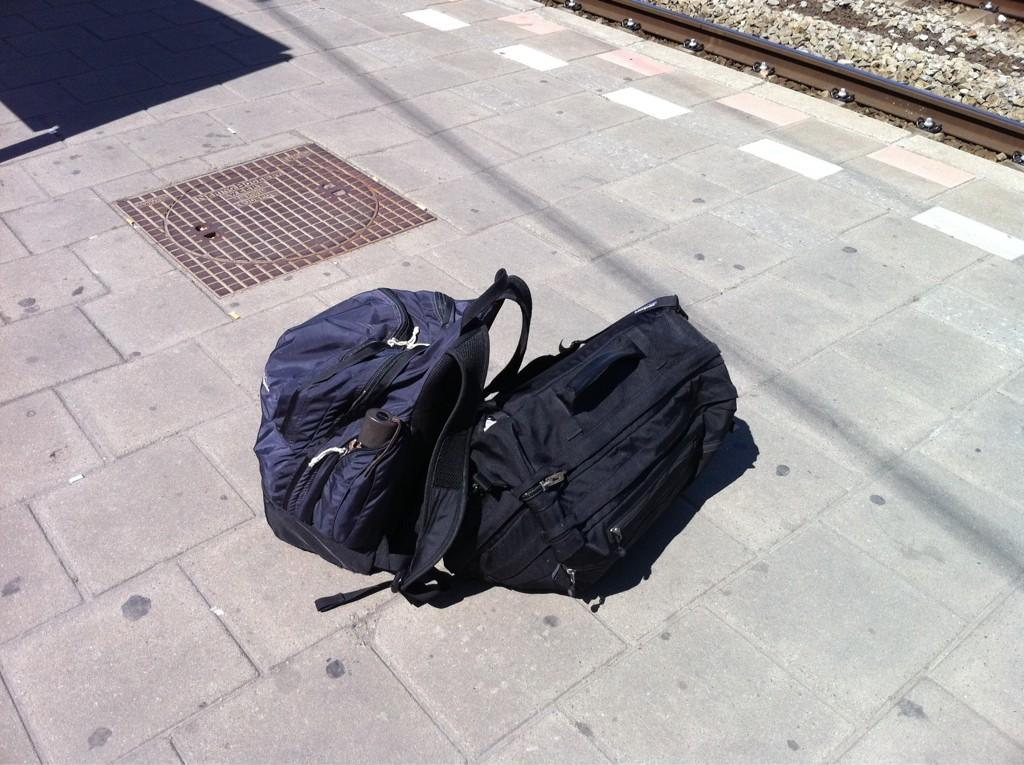What objects are on the platform in the image? There are two blue bags on a platform in the image. What other features can be seen in the image? There is a manhole lid, a shadow casting of a sign board, and a rail of a railway track in the image. What type of eggs are being used to make the pickle in the image? There is no mention of eggs or pickles in the image; it features two blue bags on a platform, a manhole lid, a shadow casting of a sign board, and a rail of a railway track. 